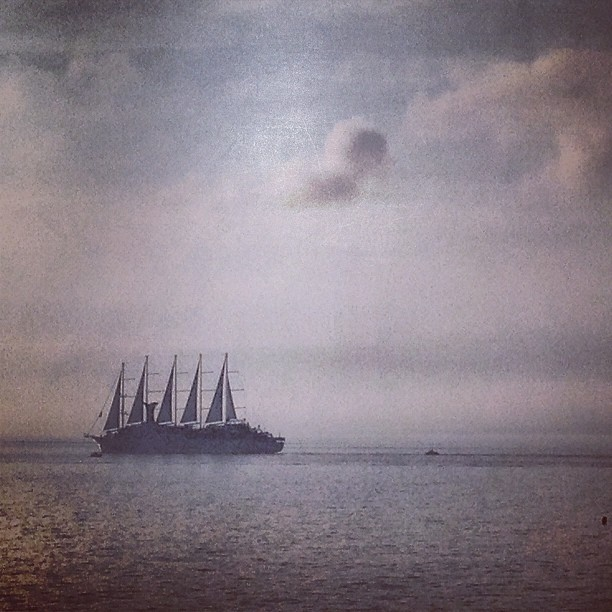Describe the objects in this image and their specific colors. I can see a boat in gray, darkgray, and black tones in this image. 